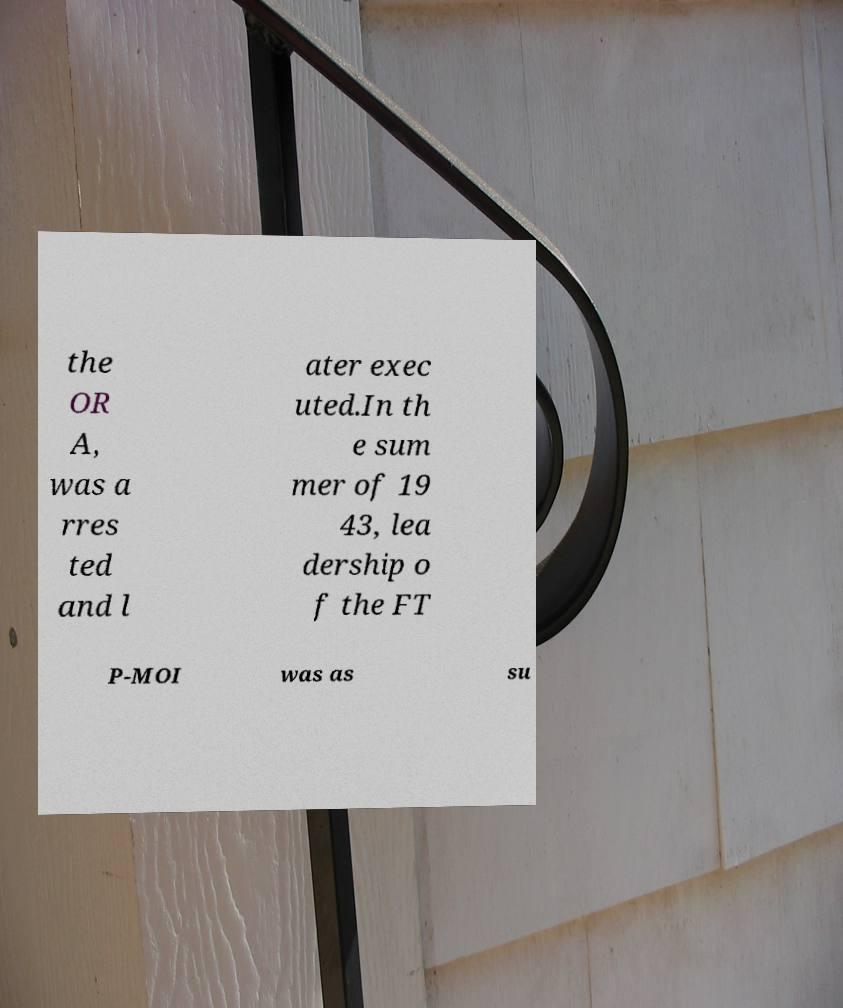I need the written content from this picture converted into text. Can you do that? the OR A, was a rres ted and l ater exec uted.In th e sum mer of 19 43, lea dership o f the FT P-MOI was as su 